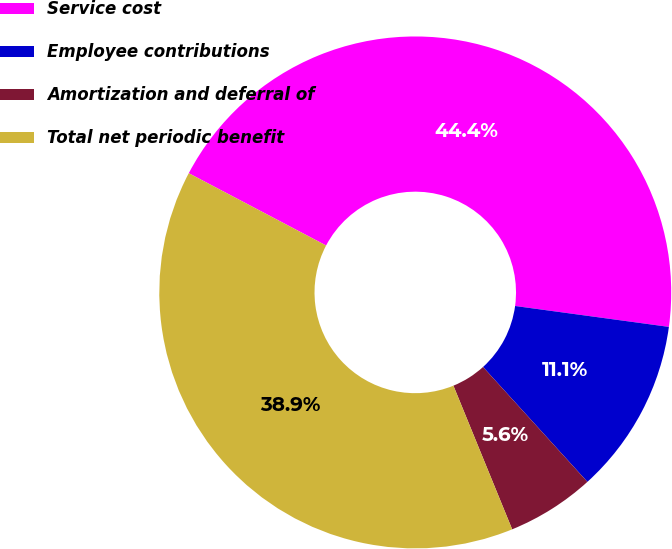Convert chart to OTSL. <chart><loc_0><loc_0><loc_500><loc_500><pie_chart><fcel>Service cost<fcel>Employee contributions<fcel>Amortization and deferral of<fcel>Total net periodic benefit<nl><fcel>44.44%<fcel>11.11%<fcel>5.56%<fcel>38.89%<nl></chart> 